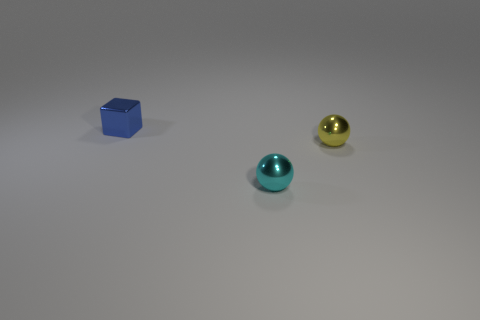Is there anything else that has the same shape as the blue object?
Keep it short and to the point. No. Are there fewer small shiny things that are on the left side of the small metal cube than small cyan balls?
Your answer should be compact. Yes. What is the size of the thing that is in front of the small ball behind the tiny sphere that is on the left side of the yellow ball?
Keep it short and to the point. Small. What is the color of the tiny object that is to the right of the blue shiny thing and left of the yellow shiny sphere?
Give a very brief answer. Cyan. How many large blue shiny blocks are there?
Provide a succinct answer. 0. Does the cyan object have the same material as the blue object?
Your response must be concise. Yes. Does the metal ball that is left of the yellow sphere have the same size as the metal thing that is on the right side of the small cyan metal ball?
Keep it short and to the point. Yes. Is the number of tiny things less than the number of cyan spheres?
Keep it short and to the point. No. What number of rubber objects are either blue objects or tiny brown objects?
Make the answer very short. 0. Is there a tiny blue object behind the tiny ball right of the cyan shiny thing?
Ensure brevity in your answer.  Yes. 